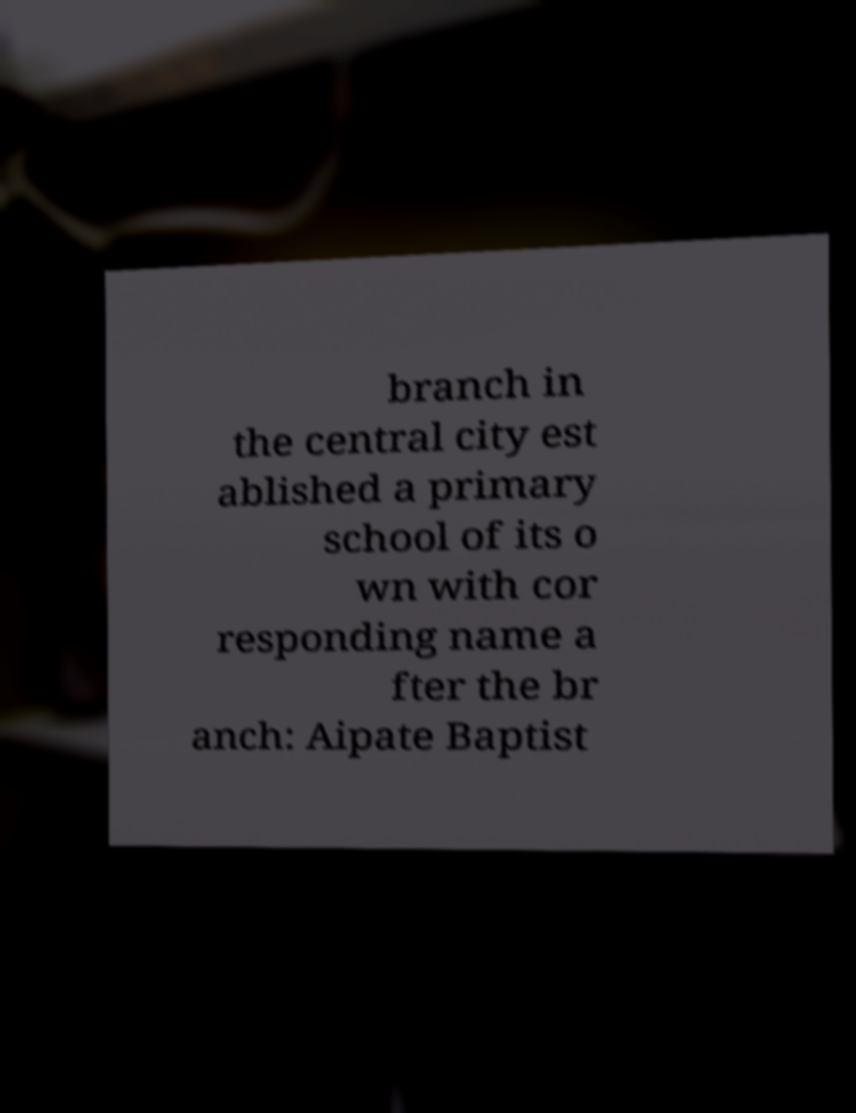Could you assist in decoding the text presented in this image and type it out clearly? branch in the central city est ablished a primary school of its o wn with cor responding name a fter the br anch: Aipate Baptist 